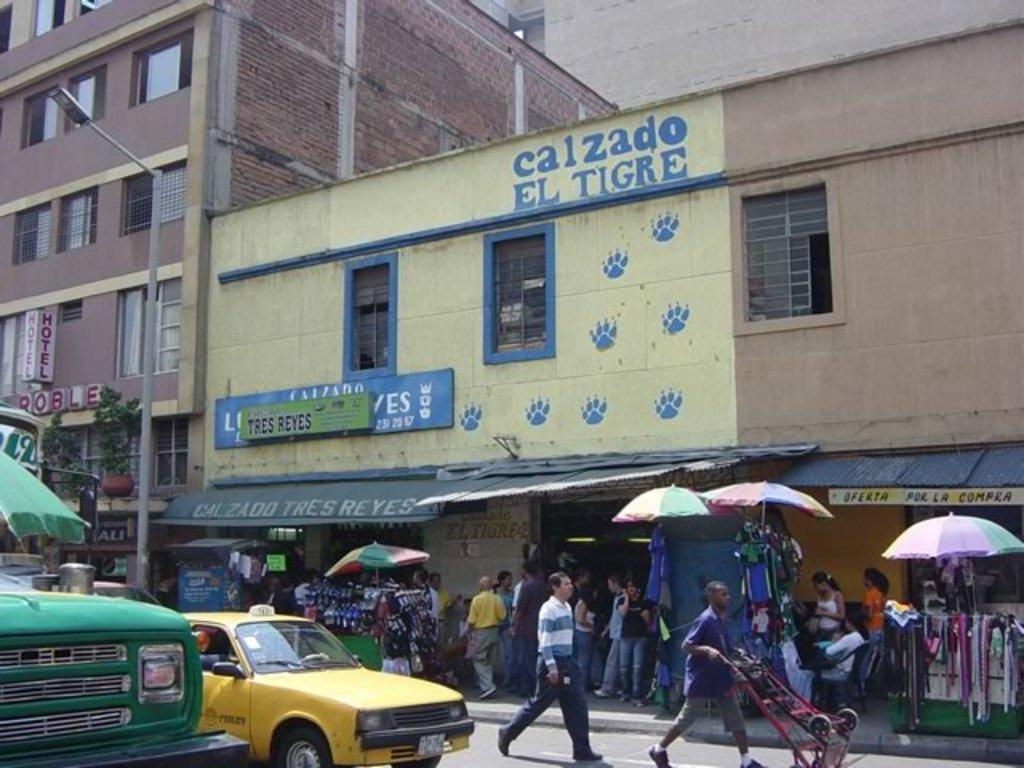<image>
Write a terse but informative summary of the picture. A man in a yellow shirt is approaching a store front called Calzado Tres Reyes. 